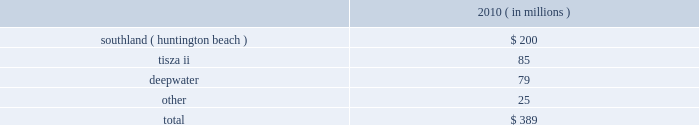The aes corporation notes to consolidated financial statements 2014 ( continued ) december 31 , 2011 , 2010 , and 2009 may require the government to acquire an ownership interest and the current expectation of future losses .
Our evaluation indicated that the long-lived assets were no longer recoverable and , accordingly , they were written down to their estimated fair value of $ 24 million based on a discounted cash flow analysis .
The long-lived assets had a carrying amount of $ 66 million prior to the recognition of asset impairment expense .
Kelanitissa is a build- operate-transfer ( bot ) generation facility and payments under its ppa are scheduled to decline over the ppa term .
It is possible that further impairment charges may be required in the future as kelanitissa gets closer to the bot date .
Kelanitissa is reported in the asia generation reportable segment .
Asset impairment expense for the year ended december 31 , 2010 consisted of : ( in millions ) .
Southland 2014in september 2010 , a new environmental policy on the use of ocean water to cool generation facilities was issued in california that requires generation plants to comply with the policy by december 31 , 2020 and would require significant capital expenditure or plants 2019 shutdown .
The company 2019s huntington beach gas-fired generation facility in california , which is part of aes 2019 southland business , was impacted by the new policy .
The company performed an asset impairment test and determined the fair value of the asset group using a discounted cash flow analysis .
The carrying value of the asset group of $ 288 million exceeded the fair value of $ 88 million resulting in the recognition of asset impairment expense of $ 200 million for the year ended december 31 , 2010 .
Southland is reported in the north america generation reportable segment .
Tisza ii 2014during the third quarter of 2010 , the company entered into annual negotiations with the offtaker of tisza ii .
As a result of these preliminary negotiations , as well as the further deterioration of the economic environment in hungary , the company determined that an indicator of impairment existed at september 30 , 2010 .
Thus , the company performed an asset impairment test and determined that based on the undiscounted cash flow analysis , the carrying amount of the tisza ii asset group was not recoverable .
The fair value of the asset group was then determined using a discounted cash flow analysis .
The carrying value of the tisza ii asset group of $ 160 million exceeded the fair value of $ 75 million resulting in the recognition of asset impairment expense of $ 85 million during the year ended december 31 , 2010 .
Deepwater 2014in 2010 , deepwater , our 160 mw petcoke-fired merchant power plant located in texas , experienced deteriorating market conditions due to increasing petcoke prices and diminishing power prices .
As a result , deepwater incurred operating losses and was shut down from time to time to avoid negative operating margin .
In the fourth quarter of 2010 , management concluded that , on an undiscounted cash flow basis , the carrying amount of the asset group was no longer recoverable .
The fair value of deepwater was determined using a discounted cash flow analysis and $ 79 million of impairment expense was recognized .
Deepwater is reported in the north america generation reportable segment. .
The deepwater write-down was what percent of total impairments? 
Computations: (79 / 389)
Answer: 0.20308. The aes corporation notes to consolidated financial statements 2014 ( continued ) december 31 , 2011 , 2010 , and 2009 may require the government to acquire an ownership interest and the current expectation of future losses .
Our evaluation indicated that the long-lived assets were no longer recoverable and , accordingly , they were written down to their estimated fair value of $ 24 million based on a discounted cash flow analysis .
The long-lived assets had a carrying amount of $ 66 million prior to the recognition of asset impairment expense .
Kelanitissa is a build- operate-transfer ( bot ) generation facility and payments under its ppa are scheduled to decline over the ppa term .
It is possible that further impairment charges may be required in the future as kelanitissa gets closer to the bot date .
Kelanitissa is reported in the asia generation reportable segment .
Asset impairment expense for the year ended december 31 , 2010 consisted of : ( in millions ) .
Southland 2014in september 2010 , a new environmental policy on the use of ocean water to cool generation facilities was issued in california that requires generation plants to comply with the policy by december 31 , 2020 and would require significant capital expenditure or plants 2019 shutdown .
The company 2019s huntington beach gas-fired generation facility in california , which is part of aes 2019 southland business , was impacted by the new policy .
The company performed an asset impairment test and determined the fair value of the asset group using a discounted cash flow analysis .
The carrying value of the asset group of $ 288 million exceeded the fair value of $ 88 million resulting in the recognition of asset impairment expense of $ 200 million for the year ended december 31 , 2010 .
Southland is reported in the north america generation reportable segment .
Tisza ii 2014during the third quarter of 2010 , the company entered into annual negotiations with the offtaker of tisza ii .
As a result of these preliminary negotiations , as well as the further deterioration of the economic environment in hungary , the company determined that an indicator of impairment existed at september 30 , 2010 .
Thus , the company performed an asset impairment test and determined that based on the undiscounted cash flow analysis , the carrying amount of the tisza ii asset group was not recoverable .
The fair value of the asset group was then determined using a discounted cash flow analysis .
The carrying value of the tisza ii asset group of $ 160 million exceeded the fair value of $ 75 million resulting in the recognition of asset impairment expense of $ 85 million during the year ended december 31 , 2010 .
Deepwater 2014in 2010 , deepwater , our 160 mw petcoke-fired merchant power plant located in texas , experienced deteriorating market conditions due to increasing petcoke prices and diminishing power prices .
As a result , deepwater incurred operating losses and was shut down from time to time to avoid negative operating margin .
In the fourth quarter of 2010 , management concluded that , on an undiscounted cash flow basis , the carrying amount of the asset group was no longer recoverable .
The fair value of deepwater was determined using a discounted cash flow analysis and $ 79 million of impairment expense was recognized .
Deepwater is reported in the north america generation reportable segment. .
What percentage was the southland ( huntington beach ) of asset impairment expense for the year ended december 31 , 2010? 
Computations: (200 / 389)
Answer: 0.51414. 